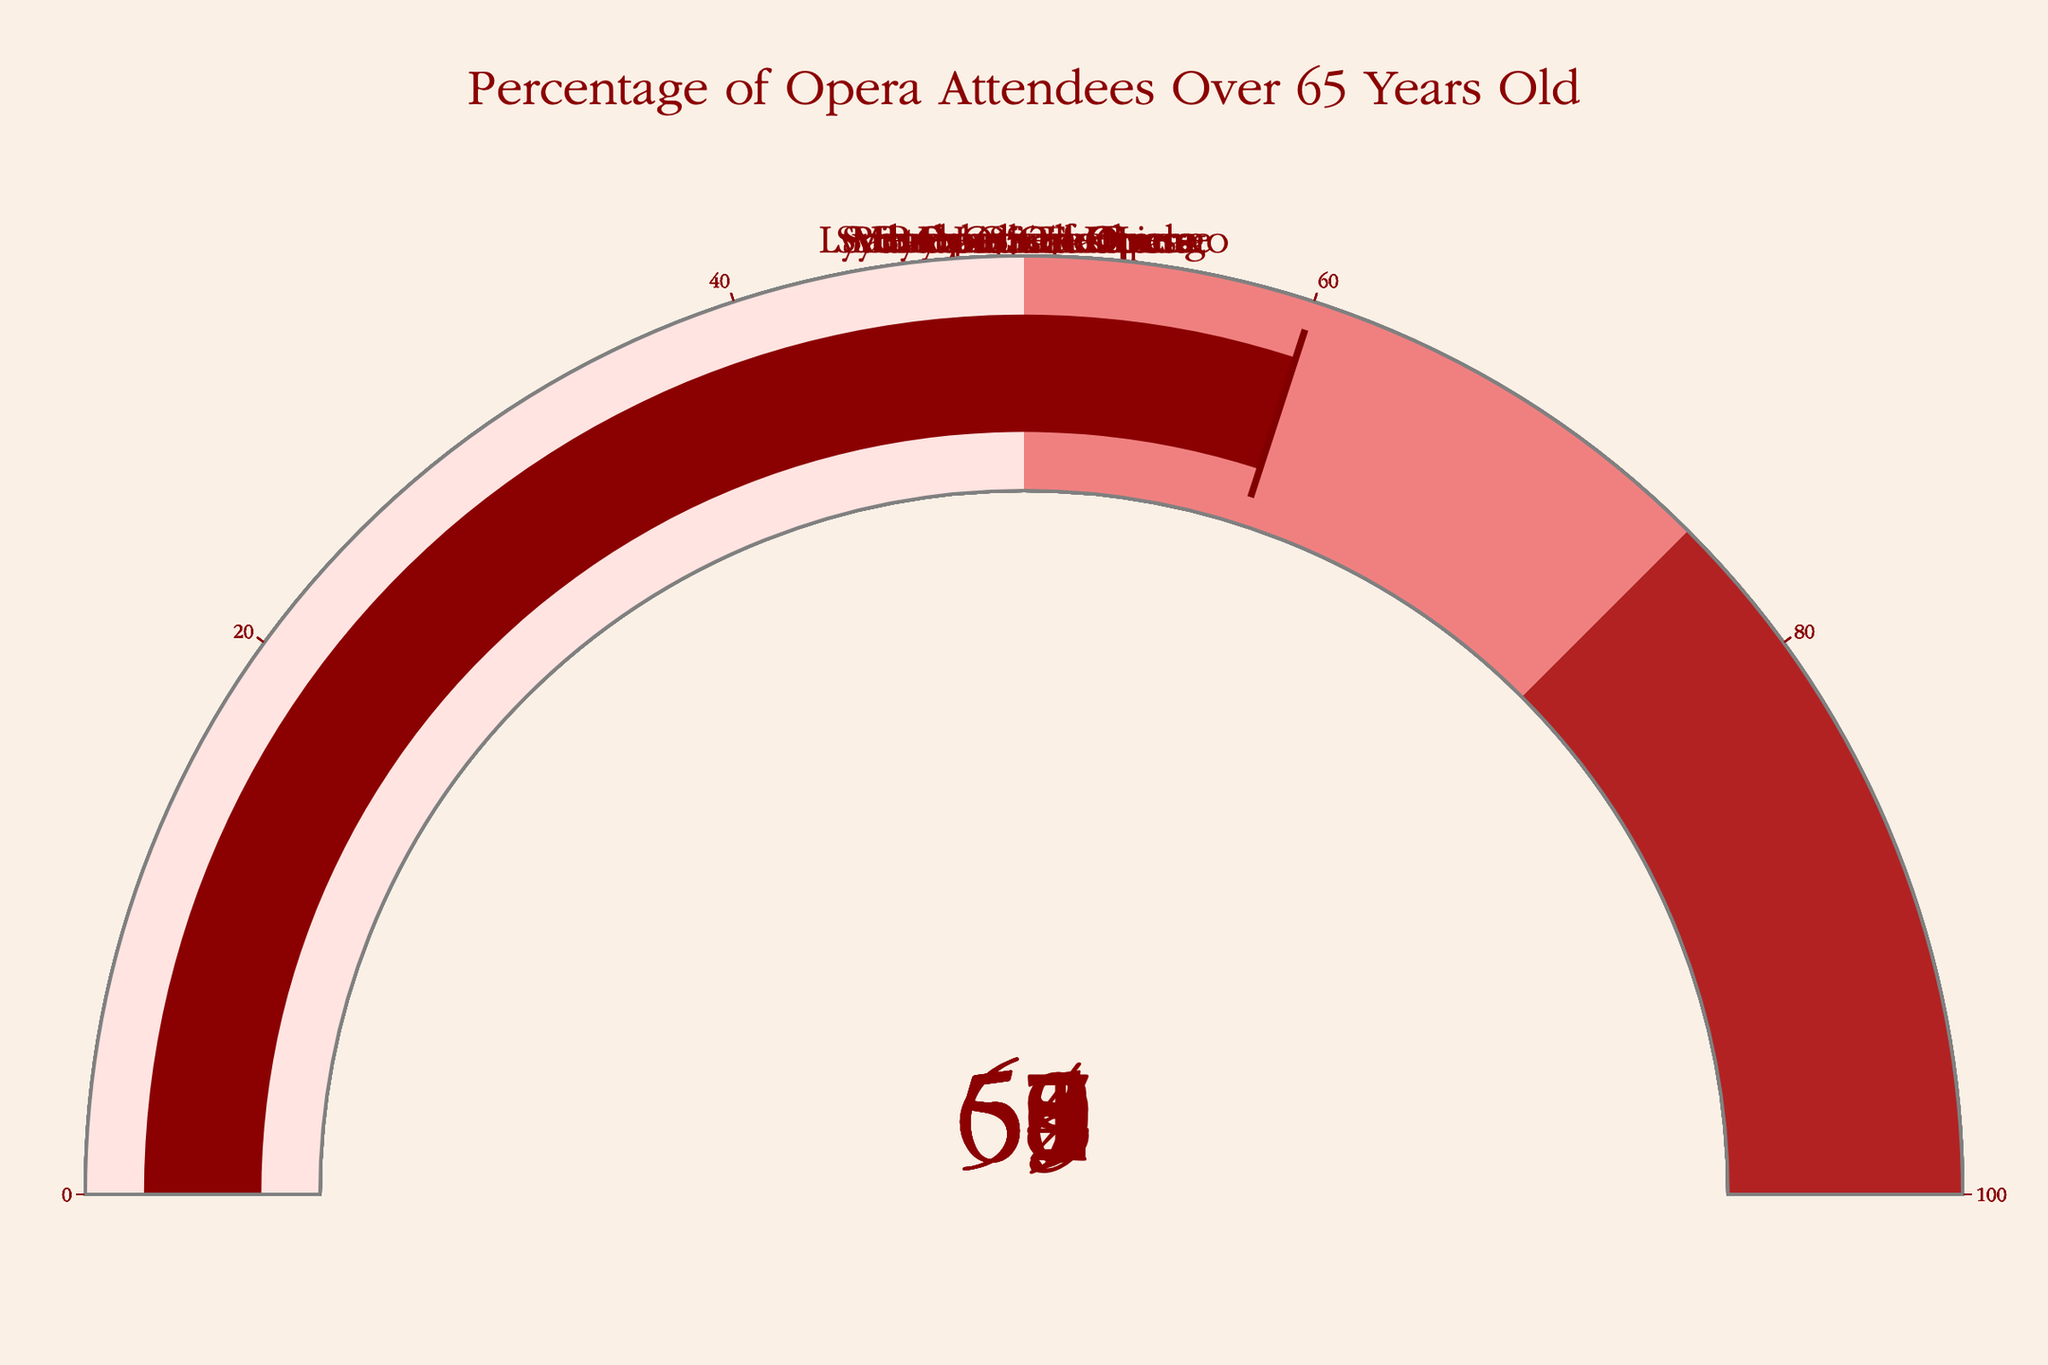Which opera house has the highest percentage of attendees over 65 years old? To find the opera house with the highest percentage, look for the gauge with the highest number displayed. La Scala shows 65%.
Answer: La Scala Which opera house has the lowest percentage of attendees over 65 years old? To determine the lowest percentage, find the gauge with the lowest number. The Sydney Opera House shows 54%.
Answer: Sydney Opera House How many opera houses have more than 60% of their attendees over 65 years old? Count the number of gauges indicating values above 60. Metropolitan Opera (62%), La Scala (65%), Lyric Opera of Chicago (61%), Bayreuth Festival (63%), Bolshoi Theatre (60%) make five opera houses.
Answer: 5 What is the average percentage of attendees over 65 years old across all the opera houses? Add all the percentages together (62 + 58 + 55 + 65 + 59 + 61 + 57 + 63 + 54 + 60 = 594) and divide by the number of opera houses, which is 10. The average is 594/10 = 59.4%.
Answer: 59.4% Which countries have opera houses with at least 60% of attendees over 65 years old? Identify the opera houses with values above 60% and locate their countries. Metropolitan Opera (USA), La Scala (Italy), Lyric Opera of Chicago (USA), Bayreuth Festival (Germany), Bolshoi Theatre (Russia).
Answer: USA, Italy, Germany, Russia What percentage of attendees over 65 years old does the Paris Opera have? Find the gauge labeled Paris Opera and read the displayed number, which is 59%.
Answer: 59% What is the difference in percentage of attendees over 65 years old between La Scala and the Royal Opera House? Subtract the percentage of Royal Opera House from La Scala (65% - 55% = 10%).
Answer: 10% Which opera house has a percentage of attendees over 65 years old closest to 60%? Look at the percentages and find the one closest to 60%. The Bolshoi Theatre shows exactly 60%.
Answer: Bolshoi Theatre Are there more opera houses with above or below 59% of attendees over 65 years old? Count how many gauges show values above 59% (5 opera houses: Metropolitan Opera, La Scala, Lyric Opera of Chicago, Bayreuth Festival, Bolshoi Theatre) and how many below or equal to 59% (5 opera houses: Vienna State Opera, Royal Opera House, Paris Opera, San Francisco Opera, Sydney Opera House).
Answer: They are equal 